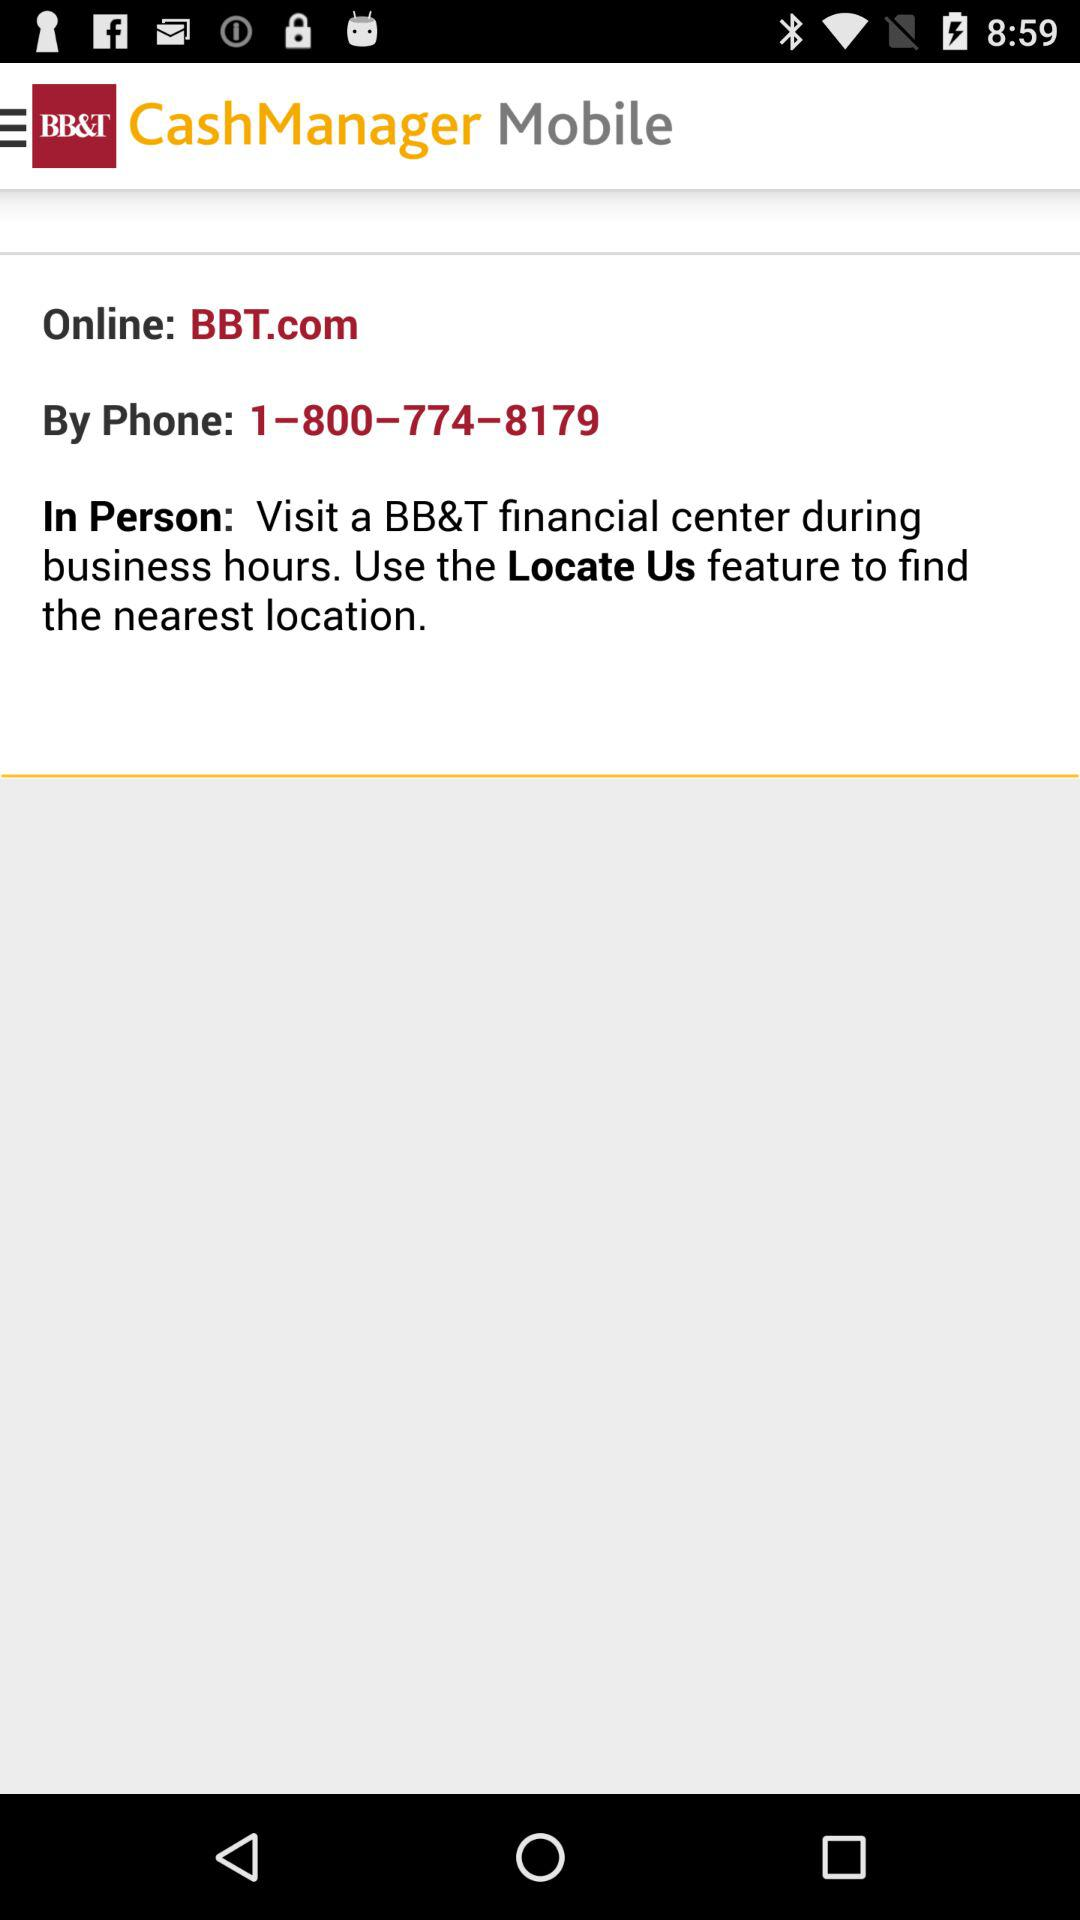What is the name of the application? The name of the application is "BB&T". 